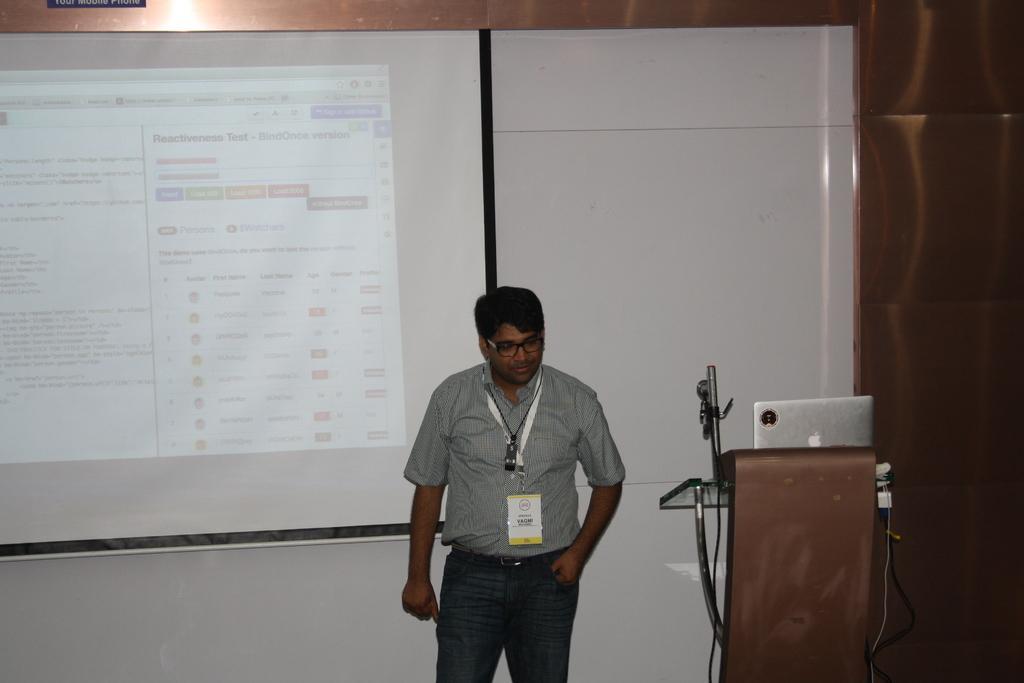Describe this image in one or two sentences. In this image there is a person standing in front of the screen on which there is a text, on the right side there is a podium, on which there are cables wires, laptop visible. 